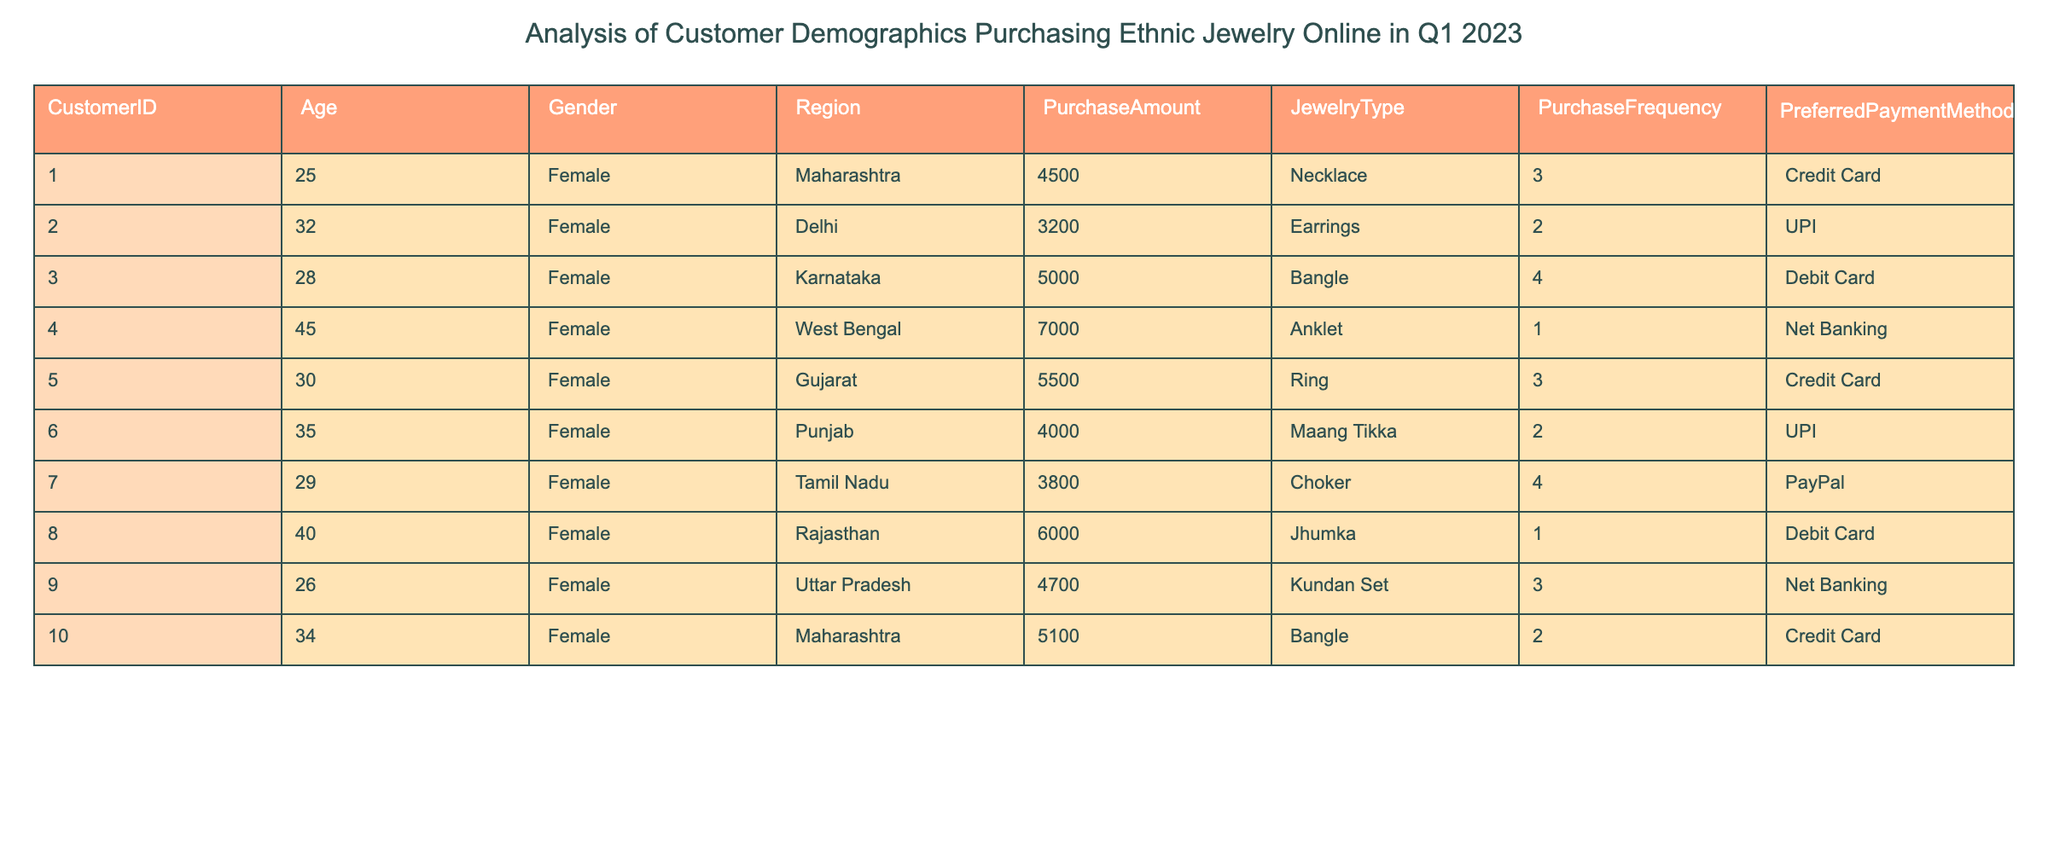What is the total purchase amount for all customers? To find the total purchase amount, I will sum up the values in the PurchaseAmount column: 4500 + 3200 + 5000 + 7000 + 5500 + 4000 + 3800 + 6000 + 4700 + 5100 = 54000.
Answer: 54000 Which region had the maximum purchase amount by a single customer? I will compare the PurchaseAmount for each customer and identify the maximum value. The highest PurchaseAmount recorded is 7000 from the West Bengal region.
Answer: West Bengal How many customers used UPI as their preferred payment method? By examining the PreferredPaymentMethod column, I will count the occurrences of "UPI." There are 2 instances (Customer 2 and Customer 6) where UPI was selected.
Answer: 2 What is the average purchase frequency of all customers? To calculate the average purchase frequency, I will sum the PurchaseFrequency values: 3 + 2 + 4 + 1 + 3 + 2 + 4 + 1 + 3 + 2 = 25, then divide by the number of customers (10): 25/10 = 2.5.
Answer: 2.5 Are there any customers who purchased jewelry items paid with PayPal? I will look through the PreferredPaymentMethod column to see if "PayPal" appears. It does appear once for Customer 7.
Answer: Yes What is the most common jewelry type purchased among the customers listed? I will check the JewelryType column and find the frequency of each type. The most frequent item is Bangle, purchased by Customers 3 and 10 (appearing twice).
Answer: Bangle What is the median purchase amount for the customers? To find the median, I will first arrange the purchase amounts in ascending order: 3200, 3800, 4000, 4500, 4700, 5000, 5100, 5500, 6000, 7000. With 10 values, the median is the average of the 5th and 6th items: (4700 + 5000)/2 = 4850.
Answer: 4850 Which age group has the highest total purchase amount? I will group data by the Age range (such as 20-29, 30-39, 40-49, etc.) and sum the PurchaseAmount for each age group. The highest total comes from the 30-39 age group with 18500 (3200 + 5000 + 5500 + 4000 + 5100).
Answer: 30-39 age group How many customers purchased items priced over 5000? By filtering the PurchaseAmount for values greater than 5000, I find that Customers 4, 5, and 8 made purchases over this amount (7000, 6000, and 5500). Counting these gives us 3 customers.
Answer: 3 